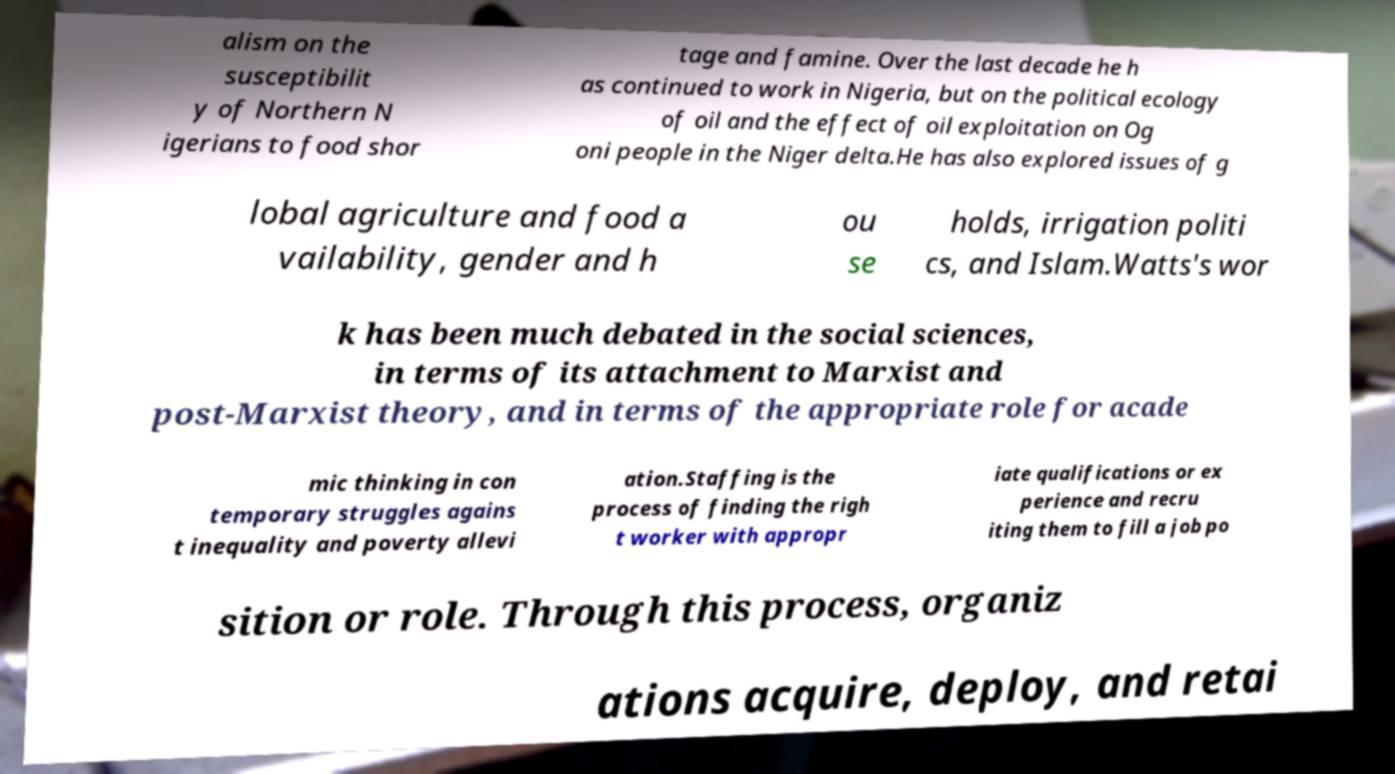What messages or text are displayed in this image? I need them in a readable, typed format. alism on the susceptibilit y of Northern N igerians to food shor tage and famine. Over the last decade he h as continued to work in Nigeria, but on the political ecology of oil and the effect of oil exploitation on Og oni people in the Niger delta.He has also explored issues of g lobal agriculture and food a vailability, gender and h ou se holds, irrigation politi cs, and Islam.Watts's wor k has been much debated in the social sciences, in terms of its attachment to Marxist and post-Marxist theory, and in terms of the appropriate role for acade mic thinking in con temporary struggles agains t inequality and poverty allevi ation.Staffing is the process of finding the righ t worker with appropr iate qualifications or ex perience and recru iting them to fill a job po sition or role. Through this process, organiz ations acquire, deploy, and retai 